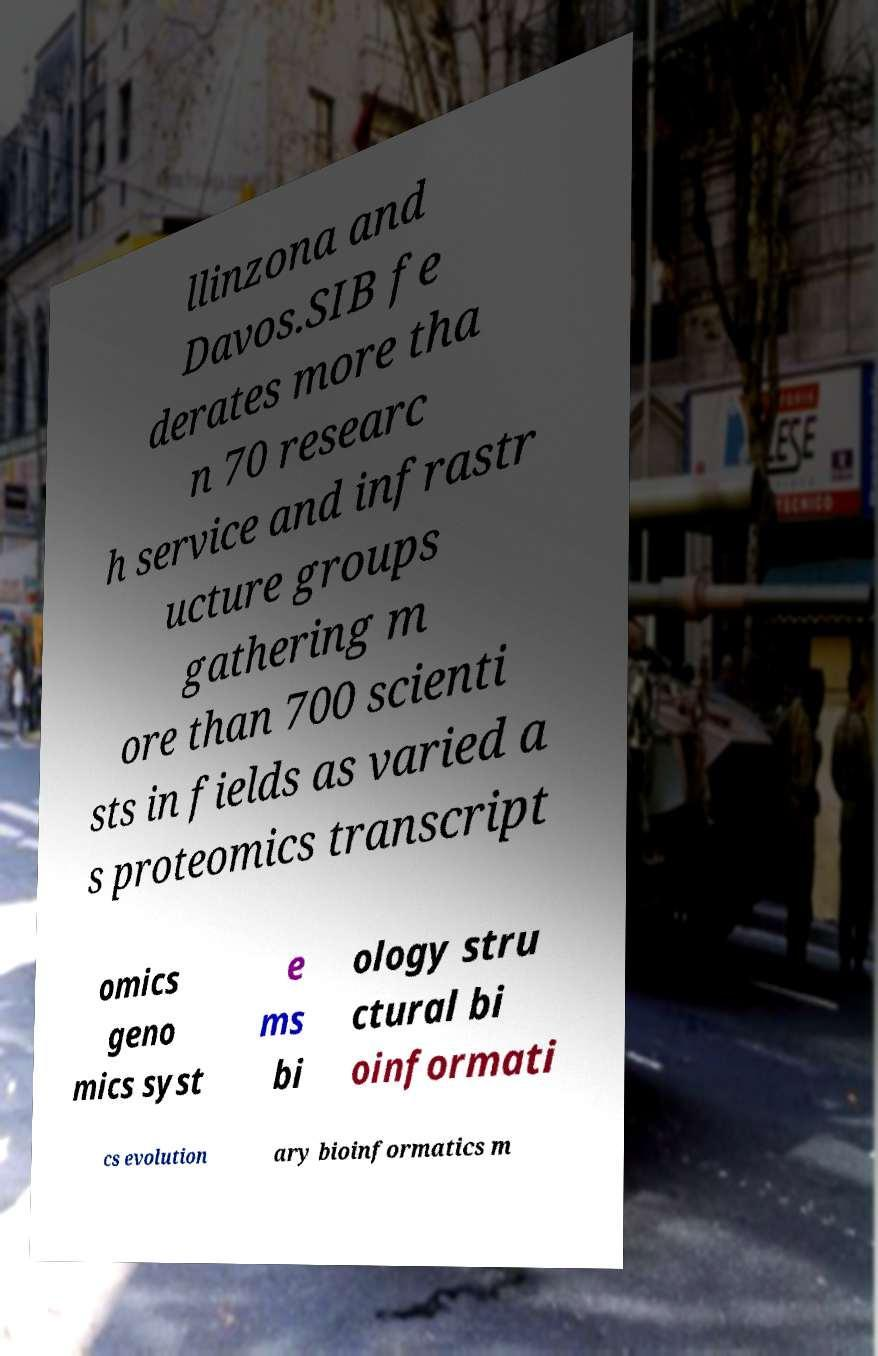For documentation purposes, I need the text within this image transcribed. Could you provide that? llinzona and Davos.SIB fe derates more tha n 70 researc h service and infrastr ucture groups gathering m ore than 700 scienti sts in fields as varied a s proteomics transcript omics geno mics syst e ms bi ology stru ctural bi oinformati cs evolution ary bioinformatics m 